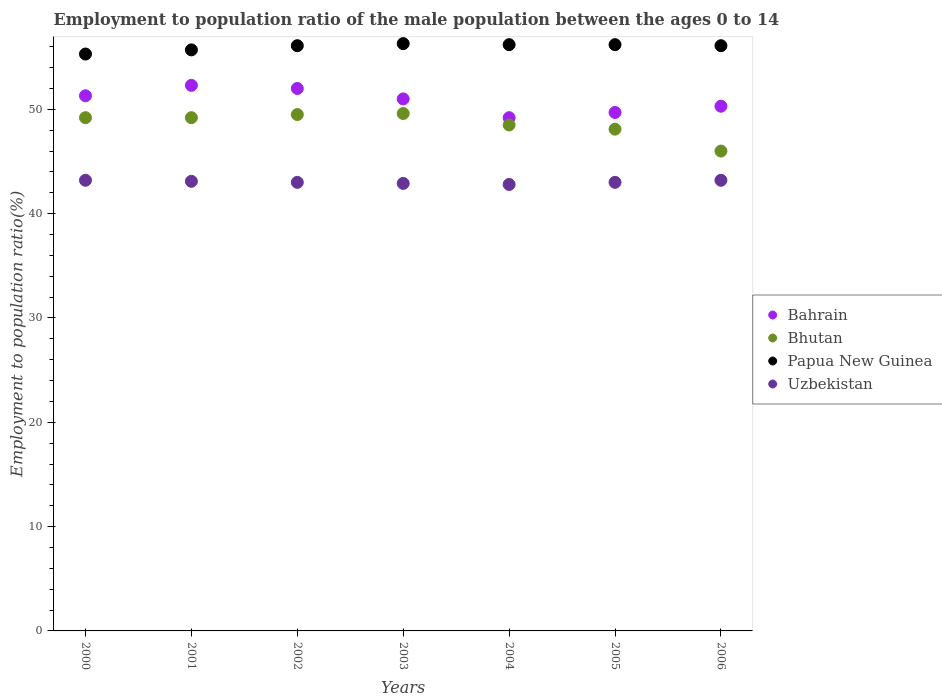Is the number of dotlines equal to the number of legend labels?
Make the answer very short. Yes. What is the employment to population ratio in Uzbekistan in 2005?
Offer a terse response. 43. Across all years, what is the maximum employment to population ratio in Bhutan?
Keep it short and to the point. 49.6. Across all years, what is the minimum employment to population ratio in Bahrain?
Provide a succinct answer. 49.2. In which year was the employment to population ratio in Uzbekistan maximum?
Give a very brief answer. 2000. In which year was the employment to population ratio in Bhutan minimum?
Your response must be concise. 2006. What is the total employment to population ratio in Uzbekistan in the graph?
Your response must be concise. 301.2. What is the difference between the employment to population ratio in Bahrain in 2001 and that in 2003?
Your response must be concise. 1.3. What is the difference between the employment to population ratio in Bhutan in 2004 and the employment to population ratio in Papua New Guinea in 2003?
Offer a terse response. -7.8. What is the average employment to population ratio in Uzbekistan per year?
Offer a very short reply. 43.03. In how many years, is the employment to population ratio in Bhutan greater than 6 %?
Make the answer very short. 7. What is the ratio of the employment to population ratio in Papua New Guinea in 2002 to that in 2006?
Offer a very short reply. 1. Is the employment to population ratio in Uzbekistan in 2001 less than that in 2002?
Your answer should be compact. No. Is the difference between the employment to population ratio in Uzbekistan in 2003 and 2005 greater than the difference between the employment to population ratio in Bahrain in 2003 and 2005?
Ensure brevity in your answer.  No. What is the difference between the highest and the second highest employment to population ratio in Bhutan?
Ensure brevity in your answer.  0.1. What is the difference between the highest and the lowest employment to population ratio in Bahrain?
Make the answer very short. 3.1. Is it the case that in every year, the sum of the employment to population ratio in Bhutan and employment to population ratio in Papua New Guinea  is greater than the sum of employment to population ratio in Uzbekistan and employment to population ratio in Bahrain?
Ensure brevity in your answer.  Yes. Does the employment to population ratio in Uzbekistan monotonically increase over the years?
Provide a short and direct response. No. Is the employment to population ratio in Bahrain strictly greater than the employment to population ratio in Uzbekistan over the years?
Your answer should be compact. Yes. Is the employment to population ratio in Bhutan strictly less than the employment to population ratio in Bahrain over the years?
Ensure brevity in your answer.  Yes. How many years are there in the graph?
Give a very brief answer. 7. What is the difference between two consecutive major ticks on the Y-axis?
Your answer should be compact. 10. Are the values on the major ticks of Y-axis written in scientific E-notation?
Your answer should be compact. No. Where does the legend appear in the graph?
Offer a terse response. Center right. How many legend labels are there?
Make the answer very short. 4. What is the title of the graph?
Your answer should be compact. Employment to population ratio of the male population between the ages 0 to 14. What is the Employment to population ratio(%) of Bahrain in 2000?
Your response must be concise. 51.3. What is the Employment to population ratio(%) of Bhutan in 2000?
Your response must be concise. 49.2. What is the Employment to population ratio(%) in Papua New Guinea in 2000?
Offer a terse response. 55.3. What is the Employment to population ratio(%) of Uzbekistan in 2000?
Give a very brief answer. 43.2. What is the Employment to population ratio(%) of Bahrain in 2001?
Your response must be concise. 52.3. What is the Employment to population ratio(%) in Bhutan in 2001?
Your answer should be very brief. 49.2. What is the Employment to population ratio(%) in Papua New Guinea in 2001?
Ensure brevity in your answer.  55.7. What is the Employment to population ratio(%) of Uzbekistan in 2001?
Your response must be concise. 43.1. What is the Employment to population ratio(%) in Bhutan in 2002?
Give a very brief answer. 49.5. What is the Employment to population ratio(%) of Papua New Guinea in 2002?
Ensure brevity in your answer.  56.1. What is the Employment to population ratio(%) of Bahrain in 2003?
Make the answer very short. 51. What is the Employment to population ratio(%) of Bhutan in 2003?
Provide a short and direct response. 49.6. What is the Employment to population ratio(%) in Papua New Guinea in 2003?
Keep it short and to the point. 56.3. What is the Employment to population ratio(%) in Uzbekistan in 2003?
Provide a succinct answer. 42.9. What is the Employment to population ratio(%) of Bahrain in 2004?
Ensure brevity in your answer.  49.2. What is the Employment to population ratio(%) in Bhutan in 2004?
Give a very brief answer. 48.5. What is the Employment to population ratio(%) in Papua New Guinea in 2004?
Provide a succinct answer. 56.2. What is the Employment to population ratio(%) of Uzbekistan in 2004?
Your answer should be compact. 42.8. What is the Employment to population ratio(%) in Bahrain in 2005?
Offer a terse response. 49.7. What is the Employment to population ratio(%) of Bhutan in 2005?
Your response must be concise. 48.1. What is the Employment to population ratio(%) of Papua New Guinea in 2005?
Your answer should be compact. 56.2. What is the Employment to population ratio(%) of Bahrain in 2006?
Give a very brief answer. 50.3. What is the Employment to population ratio(%) in Bhutan in 2006?
Offer a very short reply. 46. What is the Employment to population ratio(%) of Papua New Guinea in 2006?
Give a very brief answer. 56.1. What is the Employment to population ratio(%) of Uzbekistan in 2006?
Provide a short and direct response. 43.2. Across all years, what is the maximum Employment to population ratio(%) of Bahrain?
Provide a succinct answer. 52.3. Across all years, what is the maximum Employment to population ratio(%) in Bhutan?
Ensure brevity in your answer.  49.6. Across all years, what is the maximum Employment to population ratio(%) in Papua New Guinea?
Provide a short and direct response. 56.3. Across all years, what is the maximum Employment to population ratio(%) of Uzbekistan?
Make the answer very short. 43.2. Across all years, what is the minimum Employment to population ratio(%) in Bahrain?
Offer a very short reply. 49.2. Across all years, what is the minimum Employment to population ratio(%) of Bhutan?
Ensure brevity in your answer.  46. Across all years, what is the minimum Employment to population ratio(%) in Papua New Guinea?
Your answer should be compact. 55.3. Across all years, what is the minimum Employment to population ratio(%) in Uzbekistan?
Your answer should be compact. 42.8. What is the total Employment to population ratio(%) of Bahrain in the graph?
Ensure brevity in your answer.  355.8. What is the total Employment to population ratio(%) in Bhutan in the graph?
Make the answer very short. 340.1. What is the total Employment to population ratio(%) in Papua New Guinea in the graph?
Make the answer very short. 391.9. What is the total Employment to population ratio(%) in Uzbekistan in the graph?
Your response must be concise. 301.2. What is the difference between the Employment to population ratio(%) in Bahrain in 2000 and that in 2001?
Your response must be concise. -1. What is the difference between the Employment to population ratio(%) of Bhutan in 2000 and that in 2001?
Provide a succinct answer. 0. What is the difference between the Employment to population ratio(%) in Bahrain in 2000 and that in 2002?
Offer a very short reply. -0.7. What is the difference between the Employment to population ratio(%) of Bhutan in 2000 and that in 2004?
Keep it short and to the point. 0.7. What is the difference between the Employment to population ratio(%) in Uzbekistan in 2000 and that in 2004?
Provide a succinct answer. 0.4. What is the difference between the Employment to population ratio(%) of Papua New Guinea in 2000 and that in 2005?
Keep it short and to the point. -0.9. What is the difference between the Employment to population ratio(%) in Papua New Guinea in 2000 and that in 2006?
Provide a succinct answer. -0.8. What is the difference between the Employment to population ratio(%) of Bahrain in 2001 and that in 2002?
Provide a succinct answer. 0.3. What is the difference between the Employment to population ratio(%) in Uzbekistan in 2001 and that in 2002?
Ensure brevity in your answer.  0.1. What is the difference between the Employment to population ratio(%) of Bahrain in 2001 and that in 2003?
Offer a terse response. 1.3. What is the difference between the Employment to population ratio(%) in Bhutan in 2001 and that in 2003?
Keep it short and to the point. -0.4. What is the difference between the Employment to population ratio(%) of Uzbekistan in 2001 and that in 2003?
Keep it short and to the point. 0.2. What is the difference between the Employment to population ratio(%) of Bahrain in 2001 and that in 2004?
Ensure brevity in your answer.  3.1. What is the difference between the Employment to population ratio(%) of Papua New Guinea in 2001 and that in 2004?
Offer a terse response. -0.5. What is the difference between the Employment to population ratio(%) in Uzbekistan in 2001 and that in 2004?
Ensure brevity in your answer.  0.3. What is the difference between the Employment to population ratio(%) of Uzbekistan in 2001 and that in 2006?
Ensure brevity in your answer.  -0.1. What is the difference between the Employment to population ratio(%) in Bhutan in 2002 and that in 2003?
Keep it short and to the point. -0.1. What is the difference between the Employment to population ratio(%) of Papua New Guinea in 2002 and that in 2003?
Ensure brevity in your answer.  -0.2. What is the difference between the Employment to population ratio(%) in Bhutan in 2002 and that in 2004?
Offer a terse response. 1. What is the difference between the Employment to population ratio(%) in Bhutan in 2002 and that in 2005?
Your response must be concise. 1.4. What is the difference between the Employment to population ratio(%) in Bahrain in 2002 and that in 2006?
Provide a short and direct response. 1.7. What is the difference between the Employment to population ratio(%) of Bhutan in 2002 and that in 2006?
Give a very brief answer. 3.5. What is the difference between the Employment to population ratio(%) of Papua New Guinea in 2002 and that in 2006?
Your answer should be compact. 0. What is the difference between the Employment to population ratio(%) in Uzbekistan in 2002 and that in 2006?
Offer a very short reply. -0.2. What is the difference between the Employment to population ratio(%) of Bahrain in 2003 and that in 2004?
Keep it short and to the point. 1.8. What is the difference between the Employment to population ratio(%) in Uzbekistan in 2003 and that in 2004?
Make the answer very short. 0.1. What is the difference between the Employment to population ratio(%) of Bhutan in 2003 and that in 2005?
Give a very brief answer. 1.5. What is the difference between the Employment to population ratio(%) in Papua New Guinea in 2003 and that in 2005?
Your answer should be very brief. 0.1. What is the difference between the Employment to population ratio(%) in Uzbekistan in 2003 and that in 2005?
Your response must be concise. -0.1. What is the difference between the Employment to population ratio(%) in Bhutan in 2003 and that in 2006?
Offer a terse response. 3.6. What is the difference between the Employment to population ratio(%) of Papua New Guinea in 2003 and that in 2006?
Ensure brevity in your answer.  0.2. What is the difference between the Employment to population ratio(%) in Bahrain in 2004 and that in 2005?
Your answer should be very brief. -0.5. What is the difference between the Employment to population ratio(%) of Papua New Guinea in 2004 and that in 2005?
Give a very brief answer. 0. What is the difference between the Employment to population ratio(%) of Uzbekistan in 2004 and that in 2005?
Your response must be concise. -0.2. What is the difference between the Employment to population ratio(%) of Bhutan in 2005 and that in 2006?
Provide a succinct answer. 2.1. What is the difference between the Employment to population ratio(%) in Papua New Guinea in 2005 and that in 2006?
Give a very brief answer. 0.1. What is the difference between the Employment to population ratio(%) of Uzbekistan in 2005 and that in 2006?
Provide a short and direct response. -0.2. What is the difference between the Employment to population ratio(%) in Bahrain in 2000 and the Employment to population ratio(%) in Uzbekistan in 2001?
Your answer should be very brief. 8.2. What is the difference between the Employment to population ratio(%) of Bhutan in 2000 and the Employment to population ratio(%) of Papua New Guinea in 2001?
Offer a terse response. -6.5. What is the difference between the Employment to population ratio(%) in Bhutan in 2000 and the Employment to population ratio(%) in Uzbekistan in 2001?
Ensure brevity in your answer.  6.1. What is the difference between the Employment to population ratio(%) of Papua New Guinea in 2000 and the Employment to population ratio(%) of Uzbekistan in 2001?
Give a very brief answer. 12.2. What is the difference between the Employment to population ratio(%) of Bhutan in 2000 and the Employment to population ratio(%) of Papua New Guinea in 2002?
Your answer should be very brief. -6.9. What is the difference between the Employment to population ratio(%) in Bhutan in 2000 and the Employment to population ratio(%) in Uzbekistan in 2002?
Make the answer very short. 6.2. What is the difference between the Employment to population ratio(%) of Bahrain in 2000 and the Employment to population ratio(%) of Bhutan in 2003?
Keep it short and to the point. 1.7. What is the difference between the Employment to population ratio(%) in Bahrain in 2000 and the Employment to population ratio(%) in Papua New Guinea in 2003?
Offer a terse response. -5. What is the difference between the Employment to population ratio(%) in Bahrain in 2000 and the Employment to population ratio(%) in Uzbekistan in 2003?
Make the answer very short. 8.4. What is the difference between the Employment to population ratio(%) of Bhutan in 2000 and the Employment to population ratio(%) of Uzbekistan in 2003?
Make the answer very short. 6.3. What is the difference between the Employment to population ratio(%) of Bahrain in 2000 and the Employment to population ratio(%) of Bhutan in 2004?
Offer a terse response. 2.8. What is the difference between the Employment to population ratio(%) in Bahrain in 2000 and the Employment to population ratio(%) in Papua New Guinea in 2004?
Make the answer very short. -4.9. What is the difference between the Employment to population ratio(%) in Bahrain in 2000 and the Employment to population ratio(%) in Uzbekistan in 2004?
Ensure brevity in your answer.  8.5. What is the difference between the Employment to population ratio(%) in Bhutan in 2000 and the Employment to population ratio(%) in Uzbekistan in 2004?
Your response must be concise. 6.4. What is the difference between the Employment to population ratio(%) in Papua New Guinea in 2000 and the Employment to population ratio(%) in Uzbekistan in 2004?
Offer a very short reply. 12.5. What is the difference between the Employment to population ratio(%) of Bahrain in 2000 and the Employment to population ratio(%) of Papua New Guinea in 2005?
Ensure brevity in your answer.  -4.9. What is the difference between the Employment to population ratio(%) of Papua New Guinea in 2000 and the Employment to population ratio(%) of Uzbekistan in 2005?
Keep it short and to the point. 12.3. What is the difference between the Employment to population ratio(%) in Bahrain in 2000 and the Employment to population ratio(%) in Papua New Guinea in 2006?
Keep it short and to the point. -4.8. What is the difference between the Employment to population ratio(%) in Bhutan in 2000 and the Employment to population ratio(%) in Papua New Guinea in 2006?
Give a very brief answer. -6.9. What is the difference between the Employment to population ratio(%) of Bahrain in 2001 and the Employment to population ratio(%) of Bhutan in 2002?
Ensure brevity in your answer.  2.8. What is the difference between the Employment to population ratio(%) of Bahrain in 2001 and the Employment to population ratio(%) of Papua New Guinea in 2002?
Your response must be concise. -3.8. What is the difference between the Employment to population ratio(%) of Bhutan in 2001 and the Employment to population ratio(%) of Papua New Guinea in 2002?
Offer a very short reply. -6.9. What is the difference between the Employment to population ratio(%) in Bahrain in 2001 and the Employment to population ratio(%) in Papua New Guinea in 2003?
Give a very brief answer. -4. What is the difference between the Employment to population ratio(%) of Bahrain in 2001 and the Employment to population ratio(%) of Uzbekistan in 2003?
Provide a succinct answer. 9.4. What is the difference between the Employment to population ratio(%) in Bahrain in 2001 and the Employment to population ratio(%) in Bhutan in 2004?
Offer a terse response. 3.8. What is the difference between the Employment to population ratio(%) in Bahrain in 2001 and the Employment to population ratio(%) in Papua New Guinea in 2004?
Your answer should be very brief. -3.9. What is the difference between the Employment to population ratio(%) in Bahrain in 2001 and the Employment to population ratio(%) in Uzbekistan in 2004?
Your response must be concise. 9.5. What is the difference between the Employment to population ratio(%) of Bhutan in 2001 and the Employment to population ratio(%) of Papua New Guinea in 2004?
Your response must be concise. -7. What is the difference between the Employment to population ratio(%) of Bhutan in 2001 and the Employment to population ratio(%) of Uzbekistan in 2004?
Keep it short and to the point. 6.4. What is the difference between the Employment to population ratio(%) in Papua New Guinea in 2001 and the Employment to population ratio(%) in Uzbekistan in 2004?
Give a very brief answer. 12.9. What is the difference between the Employment to population ratio(%) of Bahrain in 2001 and the Employment to population ratio(%) of Papua New Guinea in 2005?
Ensure brevity in your answer.  -3.9. What is the difference between the Employment to population ratio(%) in Bhutan in 2001 and the Employment to population ratio(%) in Papua New Guinea in 2005?
Your answer should be compact. -7. What is the difference between the Employment to population ratio(%) of Bhutan in 2001 and the Employment to population ratio(%) of Uzbekistan in 2006?
Your answer should be compact. 6. What is the difference between the Employment to population ratio(%) of Bahrain in 2002 and the Employment to population ratio(%) of Bhutan in 2003?
Offer a terse response. 2.4. What is the difference between the Employment to population ratio(%) in Bhutan in 2002 and the Employment to population ratio(%) in Papua New Guinea in 2003?
Make the answer very short. -6.8. What is the difference between the Employment to population ratio(%) of Papua New Guinea in 2002 and the Employment to population ratio(%) of Uzbekistan in 2003?
Your response must be concise. 13.2. What is the difference between the Employment to population ratio(%) in Bahrain in 2002 and the Employment to population ratio(%) in Uzbekistan in 2004?
Keep it short and to the point. 9.2. What is the difference between the Employment to population ratio(%) of Bhutan in 2002 and the Employment to population ratio(%) of Papua New Guinea in 2004?
Give a very brief answer. -6.7. What is the difference between the Employment to population ratio(%) of Papua New Guinea in 2002 and the Employment to population ratio(%) of Uzbekistan in 2004?
Ensure brevity in your answer.  13.3. What is the difference between the Employment to population ratio(%) of Bahrain in 2002 and the Employment to population ratio(%) of Papua New Guinea in 2005?
Your response must be concise. -4.2. What is the difference between the Employment to population ratio(%) in Bhutan in 2002 and the Employment to population ratio(%) in Papua New Guinea in 2005?
Give a very brief answer. -6.7. What is the difference between the Employment to population ratio(%) of Bhutan in 2002 and the Employment to population ratio(%) of Uzbekistan in 2005?
Offer a terse response. 6.5. What is the difference between the Employment to population ratio(%) in Papua New Guinea in 2002 and the Employment to population ratio(%) in Uzbekistan in 2005?
Make the answer very short. 13.1. What is the difference between the Employment to population ratio(%) of Bahrain in 2002 and the Employment to population ratio(%) of Bhutan in 2006?
Ensure brevity in your answer.  6. What is the difference between the Employment to population ratio(%) of Bahrain in 2002 and the Employment to population ratio(%) of Uzbekistan in 2006?
Provide a short and direct response. 8.8. What is the difference between the Employment to population ratio(%) of Bhutan in 2002 and the Employment to population ratio(%) of Papua New Guinea in 2006?
Give a very brief answer. -6.6. What is the difference between the Employment to population ratio(%) in Bhutan in 2002 and the Employment to population ratio(%) in Uzbekistan in 2006?
Give a very brief answer. 6.3. What is the difference between the Employment to population ratio(%) of Papua New Guinea in 2002 and the Employment to population ratio(%) of Uzbekistan in 2006?
Offer a terse response. 12.9. What is the difference between the Employment to population ratio(%) in Bahrain in 2003 and the Employment to population ratio(%) in Bhutan in 2004?
Offer a terse response. 2.5. What is the difference between the Employment to population ratio(%) of Papua New Guinea in 2003 and the Employment to population ratio(%) of Uzbekistan in 2004?
Offer a very short reply. 13.5. What is the difference between the Employment to population ratio(%) in Bahrain in 2003 and the Employment to population ratio(%) in Papua New Guinea in 2005?
Provide a succinct answer. -5.2. What is the difference between the Employment to population ratio(%) of Bahrain in 2003 and the Employment to population ratio(%) of Uzbekistan in 2005?
Make the answer very short. 8. What is the difference between the Employment to population ratio(%) of Papua New Guinea in 2003 and the Employment to population ratio(%) of Uzbekistan in 2005?
Your response must be concise. 13.3. What is the difference between the Employment to population ratio(%) of Bahrain in 2003 and the Employment to population ratio(%) of Bhutan in 2006?
Make the answer very short. 5. What is the difference between the Employment to population ratio(%) of Bahrain in 2003 and the Employment to population ratio(%) of Papua New Guinea in 2006?
Offer a terse response. -5.1. What is the difference between the Employment to population ratio(%) in Papua New Guinea in 2003 and the Employment to population ratio(%) in Uzbekistan in 2006?
Your answer should be very brief. 13.1. What is the difference between the Employment to population ratio(%) in Bahrain in 2004 and the Employment to population ratio(%) in Papua New Guinea in 2005?
Make the answer very short. -7. What is the difference between the Employment to population ratio(%) in Bahrain in 2004 and the Employment to population ratio(%) in Uzbekistan in 2005?
Your response must be concise. 6.2. What is the difference between the Employment to population ratio(%) in Bhutan in 2004 and the Employment to population ratio(%) in Papua New Guinea in 2005?
Your answer should be very brief. -7.7. What is the difference between the Employment to population ratio(%) of Bahrain in 2004 and the Employment to population ratio(%) of Bhutan in 2006?
Ensure brevity in your answer.  3.2. What is the difference between the Employment to population ratio(%) in Papua New Guinea in 2004 and the Employment to population ratio(%) in Uzbekistan in 2006?
Ensure brevity in your answer.  13. What is the difference between the Employment to population ratio(%) of Bahrain in 2005 and the Employment to population ratio(%) of Bhutan in 2006?
Your answer should be very brief. 3.7. What is the difference between the Employment to population ratio(%) of Bhutan in 2005 and the Employment to population ratio(%) of Papua New Guinea in 2006?
Give a very brief answer. -8. What is the average Employment to population ratio(%) of Bahrain per year?
Offer a very short reply. 50.83. What is the average Employment to population ratio(%) of Bhutan per year?
Keep it short and to the point. 48.59. What is the average Employment to population ratio(%) of Papua New Guinea per year?
Provide a short and direct response. 55.99. What is the average Employment to population ratio(%) of Uzbekistan per year?
Ensure brevity in your answer.  43.03. In the year 2000, what is the difference between the Employment to population ratio(%) of Bahrain and Employment to population ratio(%) of Uzbekistan?
Provide a succinct answer. 8.1. In the year 2000, what is the difference between the Employment to population ratio(%) in Bhutan and Employment to population ratio(%) in Papua New Guinea?
Offer a terse response. -6.1. In the year 2000, what is the difference between the Employment to population ratio(%) of Bhutan and Employment to population ratio(%) of Uzbekistan?
Your answer should be very brief. 6. In the year 2000, what is the difference between the Employment to population ratio(%) of Papua New Guinea and Employment to population ratio(%) of Uzbekistan?
Provide a short and direct response. 12.1. In the year 2001, what is the difference between the Employment to population ratio(%) of Bahrain and Employment to population ratio(%) of Papua New Guinea?
Provide a short and direct response. -3.4. In the year 2001, what is the difference between the Employment to population ratio(%) in Bhutan and Employment to population ratio(%) in Papua New Guinea?
Your answer should be compact. -6.5. In the year 2001, what is the difference between the Employment to population ratio(%) in Bhutan and Employment to population ratio(%) in Uzbekistan?
Your answer should be very brief. 6.1. In the year 2002, what is the difference between the Employment to population ratio(%) in Bahrain and Employment to population ratio(%) in Papua New Guinea?
Keep it short and to the point. -4.1. In the year 2002, what is the difference between the Employment to population ratio(%) of Bhutan and Employment to population ratio(%) of Papua New Guinea?
Your response must be concise. -6.6. In the year 2002, what is the difference between the Employment to population ratio(%) of Bhutan and Employment to population ratio(%) of Uzbekistan?
Ensure brevity in your answer.  6.5. In the year 2002, what is the difference between the Employment to population ratio(%) in Papua New Guinea and Employment to population ratio(%) in Uzbekistan?
Make the answer very short. 13.1. In the year 2003, what is the difference between the Employment to population ratio(%) of Bahrain and Employment to population ratio(%) of Bhutan?
Your answer should be very brief. 1.4. In the year 2003, what is the difference between the Employment to population ratio(%) of Bahrain and Employment to population ratio(%) of Uzbekistan?
Ensure brevity in your answer.  8.1. In the year 2004, what is the difference between the Employment to population ratio(%) in Bhutan and Employment to population ratio(%) in Uzbekistan?
Ensure brevity in your answer.  5.7. In the year 2005, what is the difference between the Employment to population ratio(%) in Bahrain and Employment to population ratio(%) in Papua New Guinea?
Keep it short and to the point. -6.5. In the year 2005, what is the difference between the Employment to population ratio(%) of Bahrain and Employment to population ratio(%) of Uzbekistan?
Your response must be concise. 6.7. In the year 2005, what is the difference between the Employment to population ratio(%) of Bhutan and Employment to population ratio(%) of Papua New Guinea?
Give a very brief answer. -8.1. In the year 2006, what is the difference between the Employment to population ratio(%) in Bahrain and Employment to population ratio(%) in Bhutan?
Provide a short and direct response. 4.3. In the year 2006, what is the difference between the Employment to population ratio(%) of Bahrain and Employment to population ratio(%) of Papua New Guinea?
Give a very brief answer. -5.8. In the year 2006, what is the difference between the Employment to population ratio(%) in Bahrain and Employment to population ratio(%) in Uzbekistan?
Ensure brevity in your answer.  7.1. In the year 2006, what is the difference between the Employment to population ratio(%) of Bhutan and Employment to population ratio(%) of Papua New Guinea?
Provide a succinct answer. -10.1. In the year 2006, what is the difference between the Employment to population ratio(%) in Bhutan and Employment to population ratio(%) in Uzbekistan?
Ensure brevity in your answer.  2.8. In the year 2006, what is the difference between the Employment to population ratio(%) of Papua New Guinea and Employment to population ratio(%) of Uzbekistan?
Ensure brevity in your answer.  12.9. What is the ratio of the Employment to population ratio(%) in Bahrain in 2000 to that in 2001?
Ensure brevity in your answer.  0.98. What is the ratio of the Employment to population ratio(%) in Bahrain in 2000 to that in 2002?
Offer a very short reply. 0.99. What is the ratio of the Employment to population ratio(%) in Papua New Guinea in 2000 to that in 2002?
Make the answer very short. 0.99. What is the ratio of the Employment to population ratio(%) of Uzbekistan in 2000 to that in 2002?
Keep it short and to the point. 1. What is the ratio of the Employment to population ratio(%) of Bahrain in 2000 to that in 2003?
Your response must be concise. 1.01. What is the ratio of the Employment to population ratio(%) in Bhutan in 2000 to that in 2003?
Your answer should be compact. 0.99. What is the ratio of the Employment to population ratio(%) of Papua New Guinea in 2000 to that in 2003?
Make the answer very short. 0.98. What is the ratio of the Employment to population ratio(%) of Bahrain in 2000 to that in 2004?
Offer a terse response. 1.04. What is the ratio of the Employment to population ratio(%) of Bhutan in 2000 to that in 2004?
Make the answer very short. 1.01. What is the ratio of the Employment to population ratio(%) in Uzbekistan in 2000 to that in 2004?
Keep it short and to the point. 1.01. What is the ratio of the Employment to population ratio(%) of Bahrain in 2000 to that in 2005?
Ensure brevity in your answer.  1.03. What is the ratio of the Employment to population ratio(%) in Bhutan in 2000 to that in 2005?
Your response must be concise. 1.02. What is the ratio of the Employment to population ratio(%) in Uzbekistan in 2000 to that in 2005?
Keep it short and to the point. 1. What is the ratio of the Employment to population ratio(%) in Bahrain in 2000 to that in 2006?
Your response must be concise. 1.02. What is the ratio of the Employment to population ratio(%) of Bhutan in 2000 to that in 2006?
Your response must be concise. 1.07. What is the ratio of the Employment to population ratio(%) in Papua New Guinea in 2000 to that in 2006?
Your answer should be compact. 0.99. What is the ratio of the Employment to population ratio(%) in Papua New Guinea in 2001 to that in 2002?
Make the answer very short. 0.99. What is the ratio of the Employment to population ratio(%) of Uzbekistan in 2001 to that in 2002?
Offer a terse response. 1. What is the ratio of the Employment to population ratio(%) of Bahrain in 2001 to that in 2003?
Provide a short and direct response. 1.03. What is the ratio of the Employment to population ratio(%) of Papua New Guinea in 2001 to that in 2003?
Offer a very short reply. 0.99. What is the ratio of the Employment to population ratio(%) in Uzbekistan in 2001 to that in 2003?
Make the answer very short. 1. What is the ratio of the Employment to population ratio(%) in Bahrain in 2001 to that in 2004?
Provide a succinct answer. 1.06. What is the ratio of the Employment to population ratio(%) in Bhutan in 2001 to that in 2004?
Your answer should be compact. 1.01. What is the ratio of the Employment to population ratio(%) in Papua New Guinea in 2001 to that in 2004?
Your answer should be compact. 0.99. What is the ratio of the Employment to population ratio(%) of Uzbekistan in 2001 to that in 2004?
Offer a very short reply. 1.01. What is the ratio of the Employment to population ratio(%) in Bahrain in 2001 to that in 2005?
Offer a very short reply. 1.05. What is the ratio of the Employment to population ratio(%) of Bhutan in 2001 to that in 2005?
Provide a succinct answer. 1.02. What is the ratio of the Employment to population ratio(%) in Papua New Guinea in 2001 to that in 2005?
Your response must be concise. 0.99. What is the ratio of the Employment to population ratio(%) in Uzbekistan in 2001 to that in 2005?
Offer a terse response. 1. What is the ratio of the Employment to population ratio(%) of Bahrain in 2001 to that in 2006?
Provide a short and direct response. 1.04. What is the ratio of the Employment to population ratio(%) in Bhutan in 2001 to that in 2006?
Offer a very short reply. 1.07. What is the ratio of the Employment to population ratio(%) of Bahrain in 2002 to that in 2003?
Ensure brevity in your answer.  1.02. What is the ratio of the Employment to population ratio(%) of Bahrain in 2002 to that in 2004?
Make the answer very short. 1.06. What is the ratio of the Employment to population ratio(%) in Bhutan in 2002 to that in 2004?
Your answer should be compact. 1.02. What is the ratio of the Employment to population ratio(%) of Uzbekistan in 2002 to that in 2004?
Provide a short and direct response. 1. What is the ratio of the Employment to population ratio(%) in Bahrain in 2002 to that in 2005?
Ensure brevity in your answer.  1.05. What is the ratio of the Employment to population ratio(%) in Bhutan in 2002 to that in 2005?
Offer a very short reply. 1.03. What is the ratio of the Employment to population ratio(%) in Papua New Guinea in 2002 to that in 2005?
Offer a very short reply. 1. What is the ratio of the Employment to population ratio(%) in Uzbekistan in 2002 to that in 2005?
Your answer should be compact. 1. What is the ratio of the Employment to population ratio(%) in Bahrain in 2002 to that in 2006?
Make the answer very short. 1.03. What is the ratio of the Employment to population ratio(%) of Bhutan in 2002 to that in 2006?
Offer a very short reply. 1.08. What is the ratio of the Employment to population ratio(%) in Papua New Guinea in 2002 to that in 2006?
Give a very brief answer. 1. What is the ratio of the Employment to population ratio(%) of Bahrain in 2003 to that in 2004?
Ensure brevity in your answer.  1.04. What is the ratio of the Employment to population ratio(%) in Bhutan in 2003 to that in 2004?
Ensure brevity in your answer.  1.02. What is the ratio of the Employment to population ratio(%) in Papua New Guinea in 2003 to that in 2004?
Provide a short and direct response. 1. What is the ratio of the Employment to population ratio(%) in Uzbekistan in 2003 to that in 2004?
Ensure brevity in your answer.  1. What is the ratio of the Employment to population ratio(%) in Bahrain in 2003 to that in 2005?
Your answer should be very brief. 1.03. What is the ratio of the Employment to population ratio(%) in Bhutan in 2003 to that in 2005?
Your response must be concise. 1.03. What is the ratio of the Employment to population ratio(%) in Papua New Guinea in 2003 to that in 2005?
Give a very brief answer. 1. What is the ratio of the Employment to population ratio(%) of Uzbekistan in 2003 to that in 2005?
Keep it short and to the point. 1. What is the ratio of the Employment to population ratio(%) of Bahrain in 2003 to that in 2006?
Your answer should be very brief. 1.01. What is the ratio of the Employment to population ratio(%) of Bhutan in 2003 to that in 2006?
Offer a terse response. 1.08. What is the ratio of the Employment to population ratio(%) in Papua New Guinea in 2003 to that in 2006?
Ensure brevity in your answer.  1. What is the ratio of the Employment to population ratio(%) in Uzbekistan in 2003 to that in 2006?
Ensure brevity in your answer.  0.99. What is the ratio of the Employment to population ratio(%) of Bhutan in 2004 to that in 2005?
Keep it short and to the point. 1.01. What is the ratio of the Employment to population ratio(%) in Uzbekistan in 2004 to that in 2005?
Your response must be concise. 1. What is the ratio of the Employment to population ratio(%) of Bahrain in 2004 to that in 2006?
Give a very brief answer. 0.98. What is the ratio of the Employment to population ratio(%) in Bhutan in 2004 to that in 2006?
Provide a succinct answer. 1.05. What is the ratio of the Employment to population ratio(%) of Uzbekistan in 2004 to that in 2006?
Your answer should be compact. 0.99. What is the ratio of the Employment to population ratio(%) of Bhutan in 2005 to that in 2006?
Offer a terse response. 1.05. What is the difference between the highest and the second highest Employment to population ratio(%) of Bahrain?
Ensure brevity in your answer.  0.3. What is the difference between the highest and the second highest Employment to population ratio(%) of Bhutan?
Keep it short and to the point. 0.1. What is the difference between the highest and the second highest Employment to population ratio(%) in Papua New Guinea?
Ensure brevity in your answer.  0.1. What is the difference between the highest and the lowest Employment to population ratio(%) of Bahrain?
Ensure brevity in your answer.  3.1. What is the difference between the highest and the lowest Employment to population ratio(%) in Papua New Guinea?
Make the answer very short. 1. 